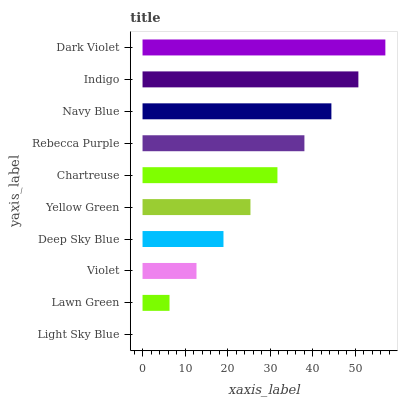Is Light Sky Blue the minimum?
Answer yes or no. Yes. Is Dark Violet the maximum?
Answer yes or no. Yes. Is Lawn Green the minimum?
Answer yes or no. No. Is Lawn Green the maximum?
Answer yes or no. No. Is Lawn Green greater than Light Sky Blue?
Answer yes or no. Yes. Is Light Sky Blue less than Lawn Green?
Answer yes or no. Yes. Is Light Sky Blue greater than Lawn Green?
Answer yes or no. No. Is Lawn Green less than Light Sky Blue?
Answer yes or no. No. Is Chartreuse the high median?
Answer yes or no. Yes. Is Yellow Green the low median?
Answer yes or no. Yes. Is Yellow Green the high median?
Answer yes or no. No. Is Violet the low median?
Answer yes or no. No. 